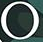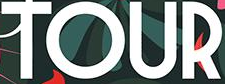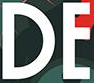What text appears in these images from left to right, separated by a semicolon? °; TOUR; DE 